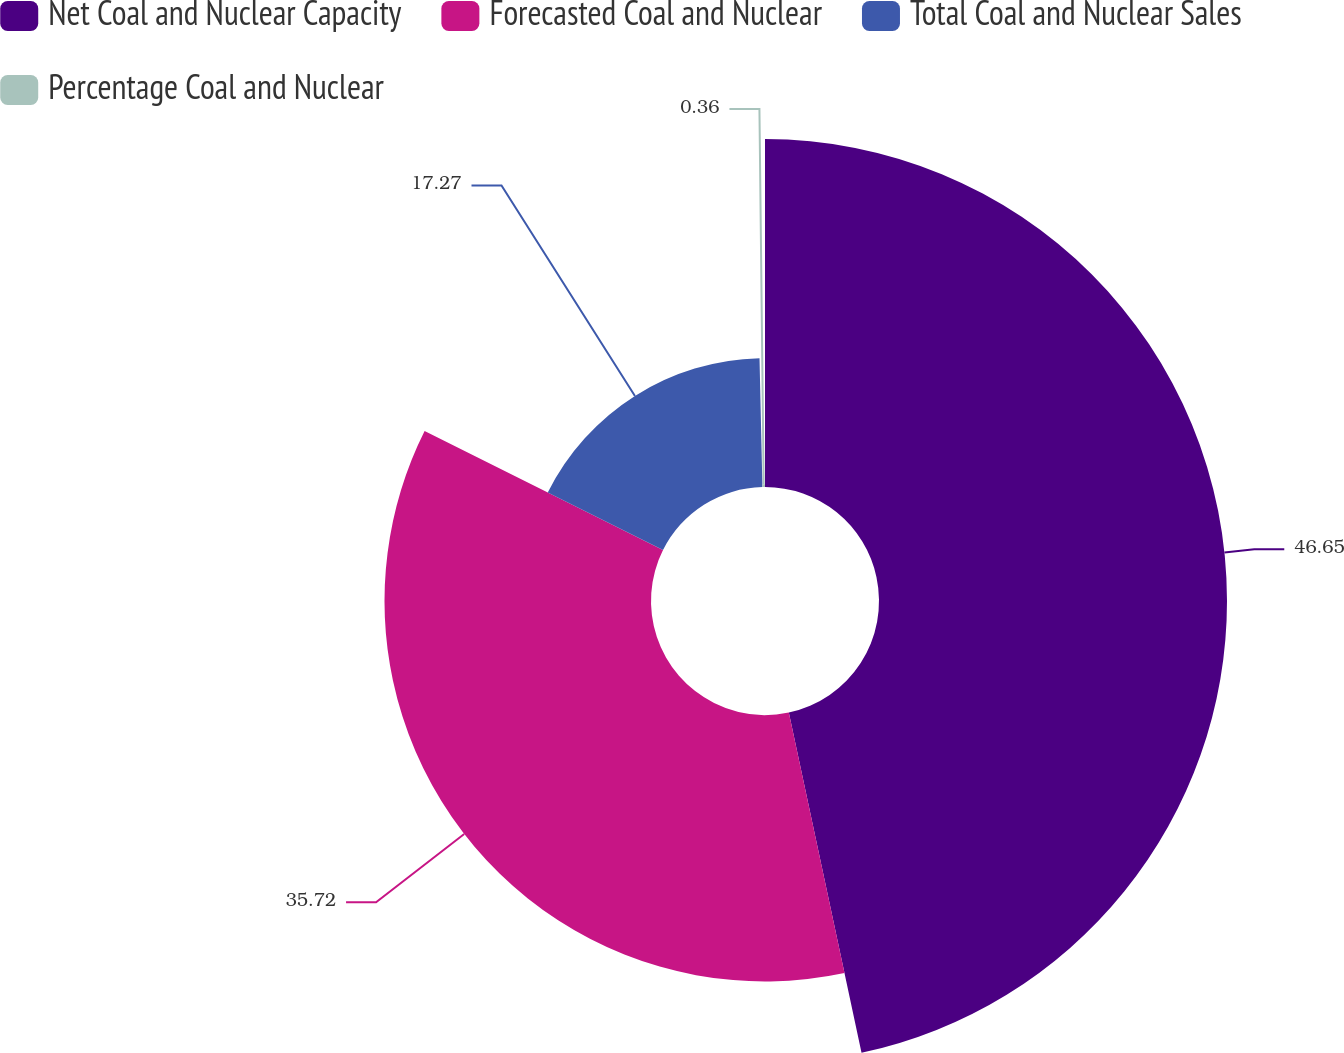Convert chart to OTSL. <chart><loc_0><loc_0><loc_500><loc_500><pie_chart><fcel>Net Coal and Nuclear Capacity<fcel>Forecasted Coal and Nuclear<fcel>Total Coal and Nuclear Sales<fcel>Percentage Coal and Nuclear<nl><fcel>46.65%<fcel>35.72%<fcel>17.27%<fcel>0.36%<nl></chart> 